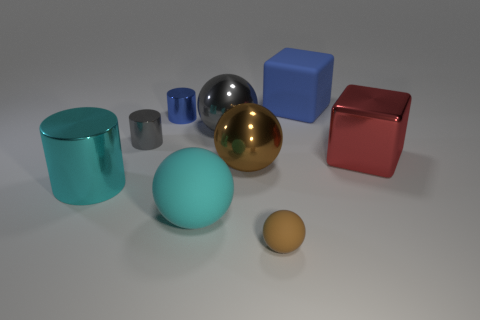Is the shape of the tiny matte object the same as the tiny shiny object that is behind the gray metal cylinder?
Give a very brief answer. No. How big is the brown object that is behind the ball to the left of the gray shiny ball?
Your answer should be compact. Large. Are there the same number of small gray metal cylinders that are in front of the big metal cylinder and objects that are to the left of the red metal thing?
Provide a short and direct response. No. There is another big matte object that is the same shape as the brown rubber object; what color is it?
Your response must be concise. Cyan. What number of tiny objects are the same color as the big matte block?
Provide a succinct answer. 1. Does the large metallic thing behind the red block have the same shape as the blue matte thing?
Offer a terse response. No. The brown thing that is to the left of the small brown matte object in front of the small gray metal thing on the left side of the tiny blue metallic cylinder is what shape?
Your response must be concise. Sphere. The gray metallic cylinder has what size?
Provide a short and direct response. Small. There is a large cube that is the same material as the small blue cylinder; what is its color?
Your answer should be compact. Red. What number of other blue objects are the same material as the large blue thing?
Offer a very short reply. 0. 